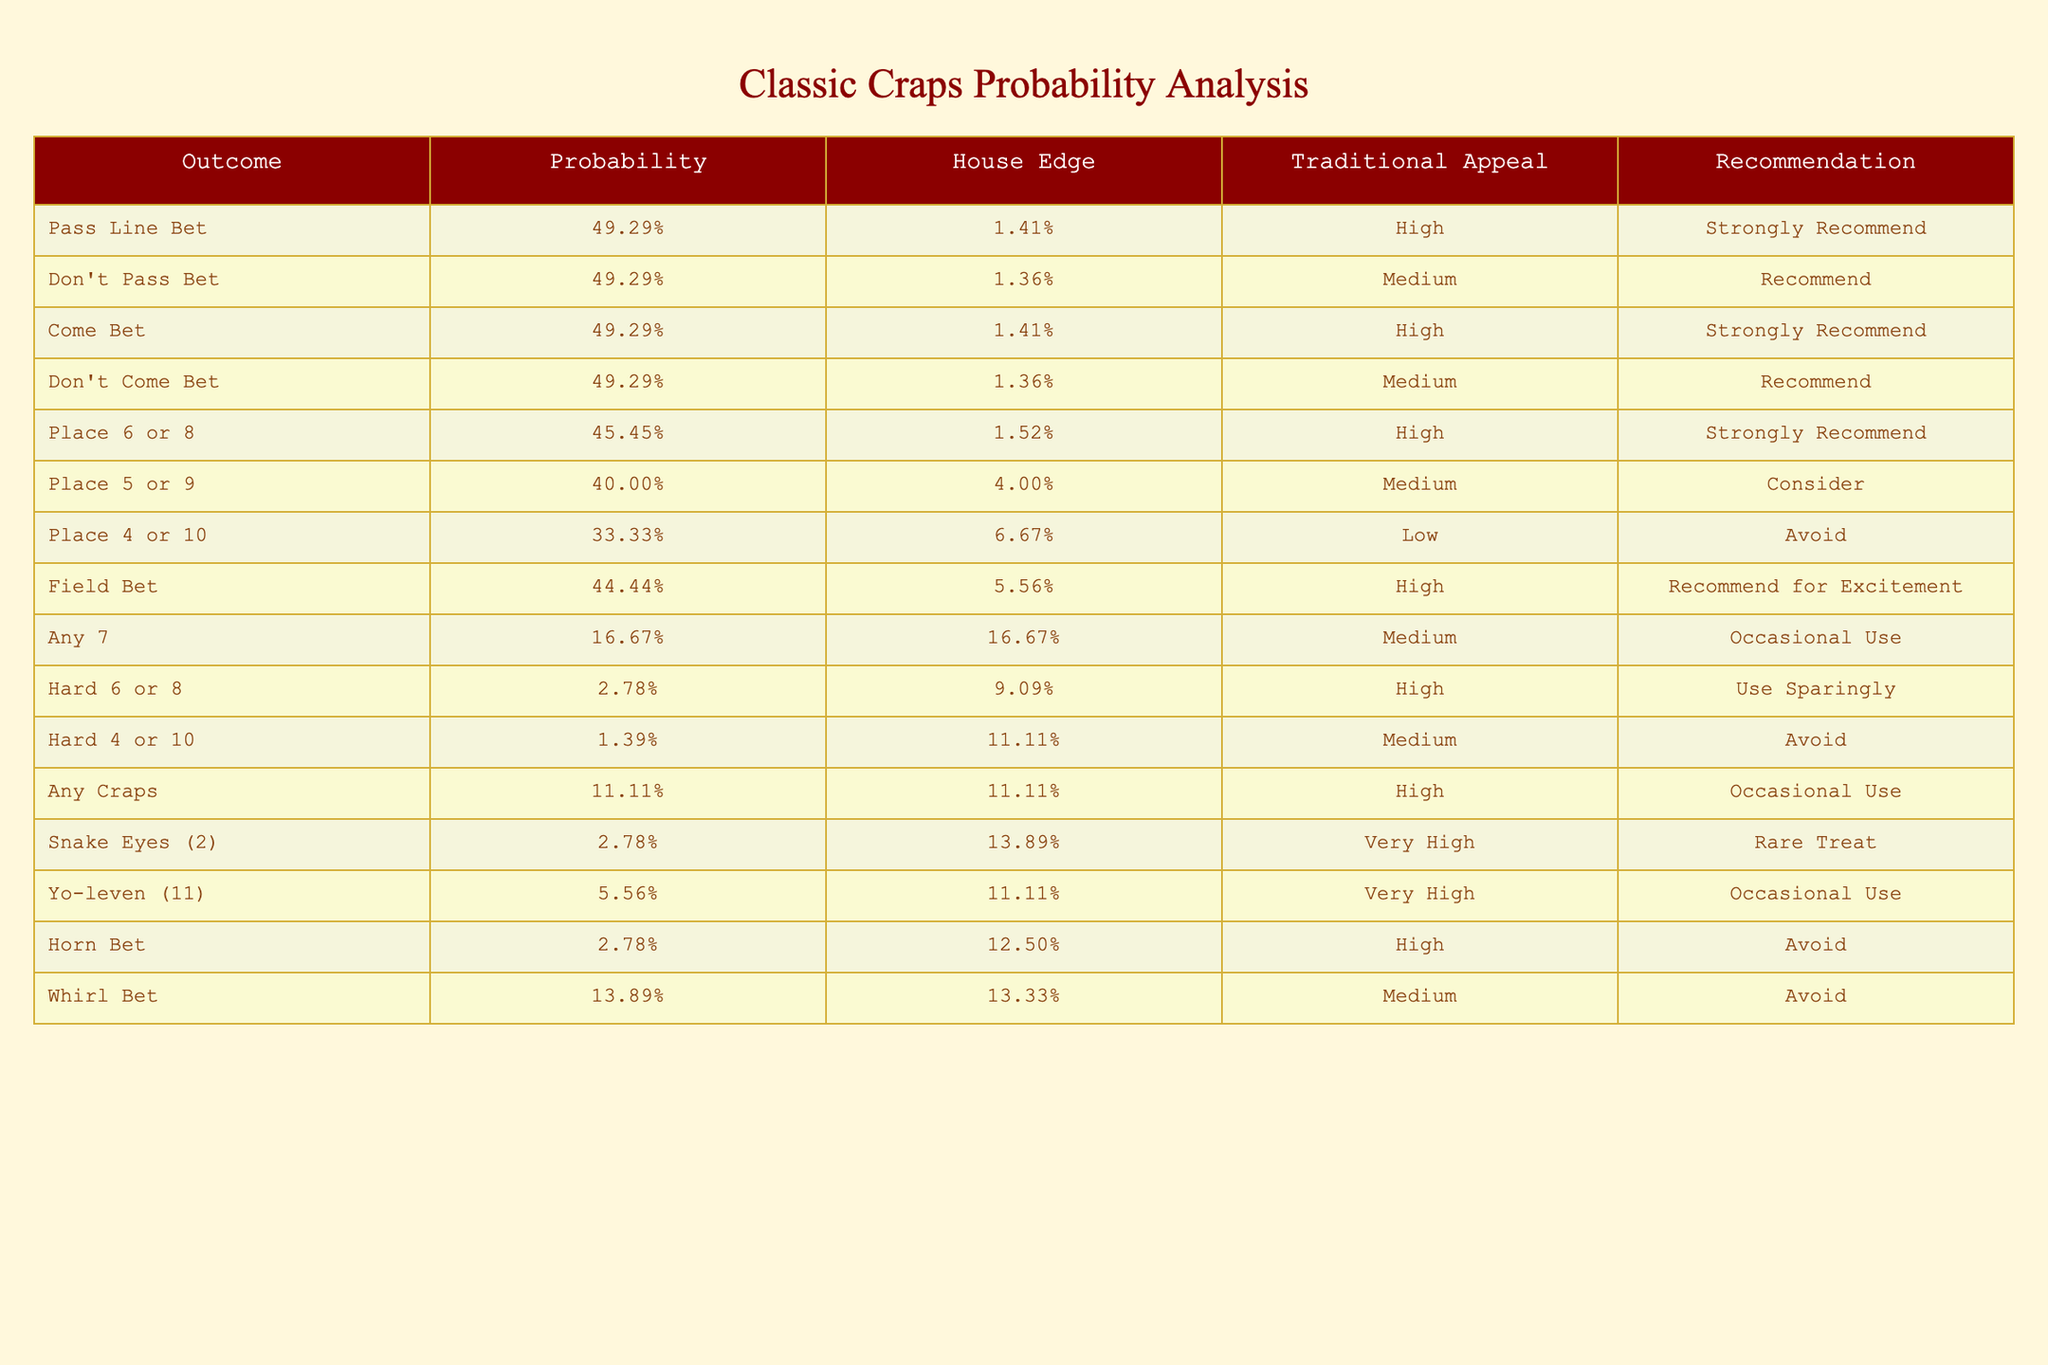What is the probability of winning with a Pass Line Bet? The table shows that the probability of winning with a Pass Line Bet is listed as 49.29%.
Answer: 49.29% Which bet has the highest house edge? By looking at the table, the bet with the highest house edge is the Any 7, with a house edge of 16.67%.
Answer: Any 7 Are Place 4 or 10 recommended for play? According to the table, Place 4 or 10 has a recommendation to avoid, suggesting it is not advised to play this bet.
Answer: No What is the average probability of winning for Place bets? The probabilities for Place 6 or 8, Place 5 or 9, and Place 4 or 10 are 45.45%, 40%, and 33.33%, respectively. To find the average: (45.45 + 40 + 33.33) / 3 = 39.26%.
Answer: 39.26% Is the recommendation for a Come Bet high, medium, or low? The table indicates that the recommendation for a Come Bet is categorized as High.
Answer: High What is the difference in house edge between Don't Pass Bet and Don't Come Bet? The house edge for Don't Pass Bet is 1.36% and for Don't Come Bet is also 1.36%. The difference is 1.36% - 1.36% = 0%.
Answer: 0% Which bets have a traditional appeal rating of "High"? Looking at the table, the bets with a traditional appeal rating of "High" include Pass Line Bet, Come Bet, Place 6 or 8, Any Craps, and Hard 6 or 8.
Answer: Pass Line Bet, Come Bet, Place 6 or 8, Any Craps, Hard 6 or 8 How many bets have a house edge greater than 10%? The bets with a house edge greater than 10% are Any 7 (16.67%), Hard 6 or 8 (9.09%), Hard 4 or 10 (11.11%), and Any Craps (11.11%), totaling to three bets.
Answer: 3 